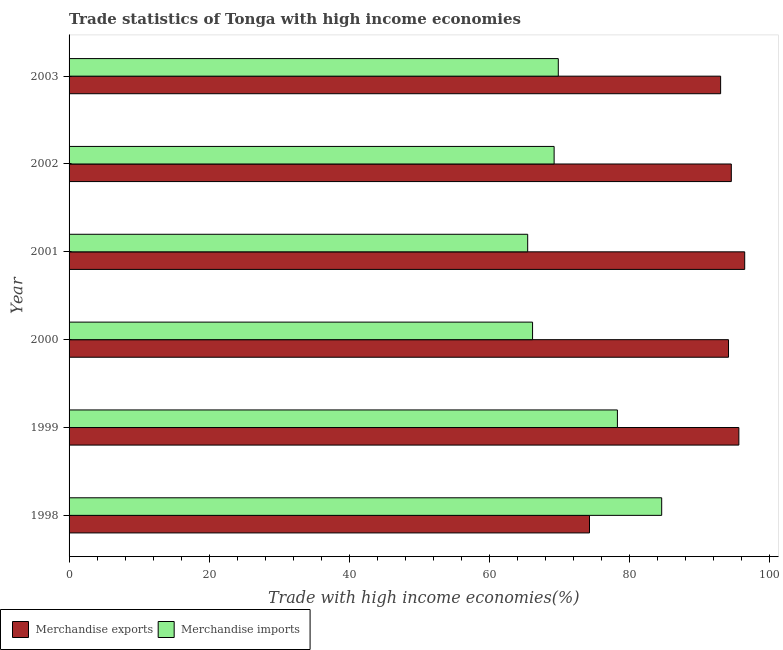Are the number of bars on each tick of the Y-axis equal?
Keep it short and to the point. Yes. How many bars are there on the 2nd tick from the bottom?
Provide a short and direct response. 2. What is the label of the 2nd group of bars from the top?
Make the answer very short. 2002. What is the merchandise imports in 2001?
Make the answer very short. 65.45. Across all years, what is the maximum merchandise imports?
Make the answer very short. 84.58. Across all years, what is the minimum merchandise exports?
Keep it short and to the point. 74.27. In which year was the merchandise imports maximum?
Keep it short and to the point. 1998. In which year was the merchandise imports minimum?
Your answer should be compact. 2001. What is the total merchandise exports in the graph?
Offer a very short reply. 547.9. What is the difference between the merchandise imports in 2000 and that in 2002?
Provide a short and direct response. -3.08. What is the difference between the merchandise exports in 2002 and the merchandise imports in 1999?
Ensure brevity in your answer.  16.26. What is the average merchandise exports per year?
Offer a very short reply. 91.32. In the year 1998, what is the difference between the merchandise exports and merchandise imports?
Offer a terse response. -10.3. What is the ratio of the merchandise imports in 2001 to that in 2003?
Keep it short and to the point. 0.94. Is the merchandise exports in 2001 less than that in 2003?
Provide a short and direct response. No. Is the difference between the merchandise exports in 1998 and 2001 greater than the difference between the merchandise imports in 1998 and 2001?
Provide a short and direct response. No. What is the difference between the highest and the second highest merchandise imports?
Your answer should be very brief. 6.32. What is the difference between the highest and the lowest merchandise imports?
Your answer should be very brief. 19.12. Is the sum of the merchandise imports in 1998 and 2000 greater than the maximum merchandise exports across all years?
Give a very brief answer. Yes. What does the 2nd bar from the top in 1998 represents?
Make the answer very short. Merchandise exports. What does the 1st bar from the bottom in 2002 represents?
Make the answer very short. Merchandise exports. What is the difference between two consecutive major ticks on the X-axis?
Make the answer very short. 20. Does the graph contain any zero values?
Offer a very short reply. No. Does the graph contain grids?
Your answer should be very brief. No. How are the legend labels stacked?
Provide a succinct answer. Horizontal. What is the title of the graph?
Make the answer very short. Trade statistics of Tonga with high income economies. What is the label or title of the X-axis?
Offer a very short reply. Trade with high income economies(%). What is the label or title of the Y-axis?
Keep it short and to the point. Year. What is the Trade with high income economies(%) in Merchandise exports in 1998?
Ensure brevity in your answer.  74.27. What is the Trade with high income economies(%) of Merchandise imports in 1998?
Offer a very short reply. 84.58. What is the Trade with high income economies(%) of Merchandise exports in 1999?
Offer a terse response. 95.59. What is the Trade with high income economies(%) of Merchandise imports in 1999?
Make the answer very short. 78.26. What is the Trade with high income economies(%) in Merchandise exports in 2000?
Your answer should be compact. 94.11. What is the Trade with high income economies(%) of Merchandise imports in 2000?
Ensure brevity in your answer.  66.15. What is the Trade with high income economies(%) in Merchandise exports in 2001?
Your response must be concise. 96.42. What is the Trade with high income economies(%) of Merchandise imports in 2001?
Make the answer very short. 65.45. What is the Trade with high income economies(%) in Merchandise exports in 2002?
Your answer should be very brief. 94.51. What is the Trade with high income economies(%) of Merchandise imports in 2002?
Provide a succinct answer. 69.22. What is the Trade with high income economies(%) of Merchandise exports in 2003?
Keep it short and to the point. 92.99. What is the Trade with high income economies(%) of Merchandise imports in 2003?
Your response must be concise. 69.82. Across all years, what is the maximum Trade with high income economies(%) of Merchandise exports?
Make the answer very short. 96.42. Across all years, what is the maximum Trade with high income economies(%) of Merchandise imports?
Give a very brief answer. 84.58. Across all years, what is the minimum Trade with high income economies(%) in Merchandise exports?
Provide a succinct answer. 74.27. Across all years, what is the minimum Trade with high income economies(%) of Merchandise imports?
Offer a very short reply. 65.45. What is the total Trade with high income economies(%) in Merchandise exports in the graph?
Give a very brief answer. 547.9. What is the total Trade with high income economies(%) of Merchandise imports in the graph?
Provide a short and direct response. 433.48. What is the difference between the Trade with high income economies(%) in Merchandise exports in 1998 and that in 1999?
Keep it short and to the point. -21.32. What is the difference between the Trade with high income economies(%) of Merchandise imports in 1998 and that in 1999?
Offer a very short reply. 6.32. What is the difference between the Trade with high income economies(%) of Merchandise exports in 1998 and that in 2000?
Give a very brief answer. -19.84. What is the difference between the Trade with high income economies(%) in Merchandise imports in 1998 and that in 2000?
Your response must be concise. 18.43. What is the difference between the Trade with high income economies(%) of Merchandise exports in 1998 and that in 2001?
Keep it short and to the point. -22.15. What is the difference between the Trade with high income economies(%) in Merchandise imports in 1998 and that in 2001?
Provide a succinct answer. 19.12. What is the difference between the Trade with high income economies(%) of Merchandise exports in 1998 and that in 2002?
Your response must be concise. -20.24. What is the difference between the Trade with high income economies(%) of Merchandise imports in 1998 and that in 2002?
Your answer should be compact. 15.35. What is the difference between the Trade with high income economies(%) in Merchandise exports in 1998 and that in 2003?
Your response must be concise. -18.71. What is the difference between the Trade with high income economies(%) in Merchandise imports in 1998 and that in 2003?
Provide a short and direct response. 14.76. What is the difference between the Trade with high income economies(%) in Merchandise exports in 1999 and that in 2000?
Offer a terse response. 1.48. What is the difference between the Trade with high income economies(%) of Merchandise imports in 1999 and that in 2000?
Your answer should be very brief. 12.11. What is the difference between the Trade with high income economies(%) of Merchandise exports in 1999 and that in 2001?
Your response must be concise. -0.84. What is the difference between the Trade with high income economies(%) in Merchandise imports in 1999 and that in 2001?
Offer a terse response. 12.8. What is the difference between the Trade with high income economies(%) in Merchandise exports in 1999 and that in 2002?
Your answer should be compact. 1.08. What is the difference between the Trade with high income economies(%) of Merchandise imports in 1999 and that in 2002?
Provide a short and direct response. 9.03. What is the difference between the Trade with high income economies(%) in Merchandise exports in 1999 and that in 2003?
Offer a very short reply. 2.6. What is the difference between the Trade with high income economies(%) of Merchandise imports in 1999 and that in 2003?
Provide a succinct answer. 8.44. What is the difference between the Trade with high income economies(%) of Merchandise exports in 2000 and that in 2001?
Provide a succinct answer. -2.31. What is the difference between the Trade with high income economies(%) of Merchandise imports in 2000 and that in 2001?
Make the answer very short. 0.7. What is the difference between the Trade with high income economies(%) in Merchandise exports in 2000 and that in 2002?
Ensure brevity in your answer.  -0.4. What is the difference between the Trade with high income economies(%) of Merchandise imports in 2000 and that in 2002?
Keep it short and to the point. -3.08. What is the difference between the Trade with high income economies(%) of Merchandise exports in 2000 and that in 2003?
Provide a succinct answer. 1.12. What is the difference between the Trade with high income economies(%) in Merchandise imports in 2000 and that in 2003?
Offer a terse response. -3.67. What is the difference between the Trade with high income economies(%) in Merchandise exports in 2001 and that in 2002?
Offer a terse response. 1.91. What is the difference between the Trade with high income economies(%) of Merchandise imports in 2001 and that in 2002?
Keep it short and to the point. -3.77. What is the difference between the Trade with high income economies(%) in Merchandise exports in 2001 and that in 2003?
Make the answer very short. 3.44. What is the difference between the Trade with high income economies(%) in Merchandise imports in 2001 and that in 2003?
Provide a short and direct response. -4.37. What is the difference between the Trade with high income economies(%) in Merchandise exports in 2002 and that in 2003?
Your answer should be compact. 1.53. What is the difference between the Trade with high income economies(%) in Merchandise imports in 2002 and that in 2003?
Ensure brevity in your answer.  -0.6. What is the difference between the Trade with high income economies(%) in Merchandise exports in 1998 and the Trade with high income economies(%) in Merchandise imports in 1999?
Ensure brevity in your answer.  -3.98. What is the difference between the Trade with high income economies(%) of Merchandise exports in 1998 and the Trade with high income economies(%) of Merchandise imports in 2000?
Your response must be concise. 8.13. What is the difference between the Trade with high income economies(%) in Merchandise exports in 1998 and the Trade with high income economies(%) in Merchandise imports in 2001?
Keep it short and to the point. 8.82. What is the difference between the Trade with high income economies(%) in Merchandise exports in 1998 and the Trade with high income economies(%) in Merchandise imports in 2002?
Ensure brevity in your answer.  5.05. What is the difference between the Trade with high income economies(%) in Merchandise exports in 1998 and the Trade with high income economies(%) in Merchandise imports in 2003?
Provide a short and direct response. 4.45. What is the difference between the Trade with high income economies(%) of Merchandise exports in 1999 and the Trade with high income economies(%) of Merchandise imports in 2000?
Give a very brief answer. 29.44. What is the difference between the Trade with high income economies(%) of Merchandise exports in 1999 and the Trade with high income economies(%) of Merchandise imports in 2001?
Provide a short and direct response. 30.14. What is the difference between the Trade with high income economies(%) in Merchandise exports in 1999 and the Trade with high income economies(%) in Merchandise imports in 2002?
Offer a terse response. 26.36. What is the difference between the Trade with high income economies(%) in Merchandise exports in 1999 and the Trade with high income economies(%) in Merchandise imports in 2003?
Give a very brief answer. 25.77. What is the difference between the Trade with high income economies(%) of Merchandise exports in 2000 and the Trade with high income economies(%) of Merchandise imports in 2001?
Your response must be concise. 28.66. What is the difference between the Trade with high income economies(%) of Merchandise exports in 2000 and the Trade with high income economies(%) of Merchandise imports in 2002?
Keep it short and to the point. 24.89. What is the difference between the Trade with high income economies(%) of Merchandise exports in 2000 and the Trade with high income economies(%) of Merchandise imports in 2003?
Offer a terse response. 24.29. What is the difference between the Trade with high income economies(%) in Merchandise exports in 2001 and the Trade with high income economies(%) in Merchandise imports in 2002?
Offer a terse response. 27.2. What is the difference between the Trade with high income economies(%) in Merchandise exports in 2001 and the Trade with high income economies(%) in Merchandise imports in 2003?
Offer a terse response. 26.6. What is the difference between the Trade with high income economies(%) in Merchandise exports in 2002 and the Trade with high income economies(%) in Merchandise imports in 2003?
Give a very brief answer. 24.69. What is the average Trade with high income economies(%) in Merchandise exports per year?
Give a very brief answer. 91.32. What is the average Trade with high income economies(%) in Merchandise imports per year?
Provide a short and direct response. 72.25. In the year 1998, what is the difference between the Trade with high income economies(%) in Merchandise exports and Trade with high income economies(%) in Merchandise imports?
Offer a very short reply. -10.3. In the year 1999, what is the difference between the Trade with high income economies(%) in Merchandise exports and Trade with high income economies(%) in Merchandise imports?
Offer a terse response. 17.33. In the year 2000, what is the difference between the Trade with high income economies(%) of Merchandise exports and Trade with high income economies(%) of Merchandise imports?
Ensure brevity in your answer.  27.96. In the year 2001, what is the difference between the Trade with high income economies(%) of Merchandise exports and Trade with high income economies(%) of Merchandise imports?
Your answer should be very brief. 30.97. In the year 2002, what is the difference between the Trade with high income economies(%) in Merchandise exports and Trade with high income economies(%) in Merchandise imports?
Your response must be concise. 25.29. In the year 2003, what is the difference between the Trade with high income economies(%) of Merchandise exports and Trade with high income economies(%) of Merchandise imports?
Offer a very short reply. 23.17. What is the ratio of the Trade with high income economies(%) in Merchandise exports in 1998 to that in 1999?
Give a very brief answer. 0.78. What is the ratio of the Trade with high income economies(%) in Merchandise imports in 1998 to that in 1999?
Provide a succinct answer. 1.08. What is the ratio of the Trade with high income economies(%) in Merchandise exports in 1998 to that in 2000?
Keep it short and to the point. 0.79. What is the ratio of the Trade with high income economies(%) of Merchandise imports in 1998 to that in 2000?
Offer a terse response. 1.28. What is the ratio of the Trade with high income economies(%) of Merchandise exports in 1998 to that in 2001?
Your response must be concise. 0.77. What is the ratio of the Trade with high income economies(%) in Merchandise imports in 1998 to that in 2001?
Provide a succinct answer. 1.29. What is the ratio of the Trade with high income economies(%) in Merchandise exports in 1998 to that in 2002?
Keep it short and to the point. 0.79. What is the ratio of the Trade with high income economies(%) of Merchandise imports in 1998 to that in 2002?
Your answer should be compact. 1.22. What is the ratio of the Trade with high income economies(%) in Merchandise exports in 1998 to that in 2003?
Ensure brevity in your answer.  0.8. What is the ratio of the Trade with high income economies(%) of Merchandise imports in 1998 to that in 2003?
Ensure brevity in your answer.  1.21. What is the ratio of the Trade with high income economies(%) in Merchandise exports in 1999 to that in 2000?
Your answer should be compact. 1.02. What is the ratio of the Trade with high income economies(%) of Merchandise imports in 1999 to that in 2000?
Offer a terse response. 1.18. What is the ratio of the Trade with high income economies(%) of Merchandise exports in 1999 to that in 2001?
Offer a terse response. 0.99. What is the ratio of the Trade with high income economies(%) of Merchandise imports in 1999 to that in 2001?
Your response must be concise. 1.2. What is the ratio of the Trade with high income economies(%) of Merchandise exports in 1999 to that in 2002?
Your answer should be very brief. 1.01. What is the ratio of the Trade with high income economies(%) in Merchandise imports in 1999 to that in 2002?
Make the answer very short. 1.13. What is the ratio of the Trade with high income economies(%) of Merchandise exports in 1999 to that in 2003?
Provide a short and direct response. 1.03. What is the ratio of the Trade with high income economies(%) of Merchandise imports in 1999 to that in 2003?
Your answer should be compact. 1.12. What is the ratio of the Trade with high income economies(%) in Merchandise exports in 2000 to that in 2001?
Provide a succinct answer. 0.98. What is the ratio of the Trade with high income economies(%) in Merchandise imports in 2000 to that in 2001?
Provide a short and direct response. 1.01. What is the ratio of the Trade with high income economies(%) of Merchandise exports in 2000 to that in 2002?
Your answer should be compact. 1. What is the ratio of the Trade with high income economies(%) in Merchandise imports in 2000 to that in 2002?
Your answer should be compact. 0.96. What is the ratio of the Trade with high income economies(%) of Merchandise exports in 2000 to that in 2003?
Offer a terse response. 1.01. What is the ratio of the Trade with high income economies(%) in Merchandise exports in 2001 to that in 2002?
Give a very brief answer. 1.02. What is the ratio of the Trade with high income economies(%) in Merchandise imports in 2001 to that in 2002?
Your answer should be very brief. 0.95. What is the ratio of the Trade with high income economies(%) in Merchandise imports in 2001 to that in 2003?
Ensure brevity in your answer.  0.94. What is the ratio of the Trade with high income economies(%) in Merchandise exports in 2002 to that in 2003?
Offer a terse response. 1.02. What is the ratio of the Trade with high income economies(%) in Merchandise imports in 2002 to that in 2003?
Offer a very short reply. 0.99. What is the difference between the highest and the second highest Trade with high income economies(%) in Merchandise exports?
Keep it short and to the point. 0.84. What is the difference between the highest and the second highest Trade with high income economies(%) in Merchandise imports?
Give a very brief answer. 6.32. What is the difference between the highest and the lowest Trade with high income economies(%) in Merchandise exports?
Make the answer very short. 22.15. What is the difference between the highest and the lowest Trade with high income economies(%) in Merchandise imports?
Offer a very short reply. 19.12. 